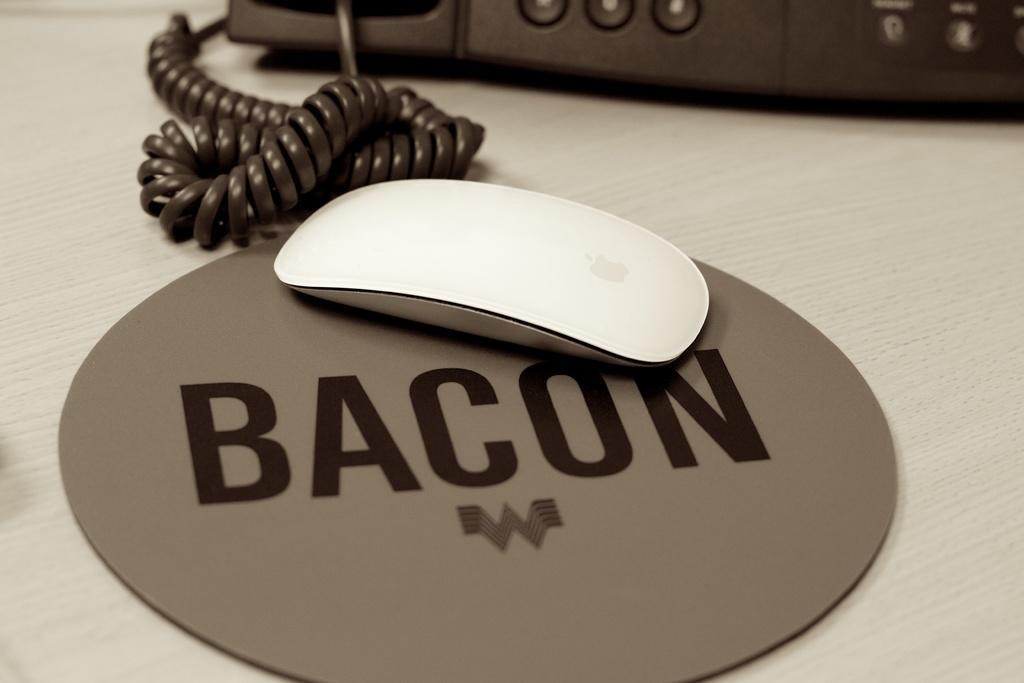What type of animal is in the image? There is a white mouse in the image. What object is also present in the image? There is a telephone in the image. What color is the smoke coming out of the car in the image? There is no car or smoke present in the image; it only features a white mouse and a telephone. 